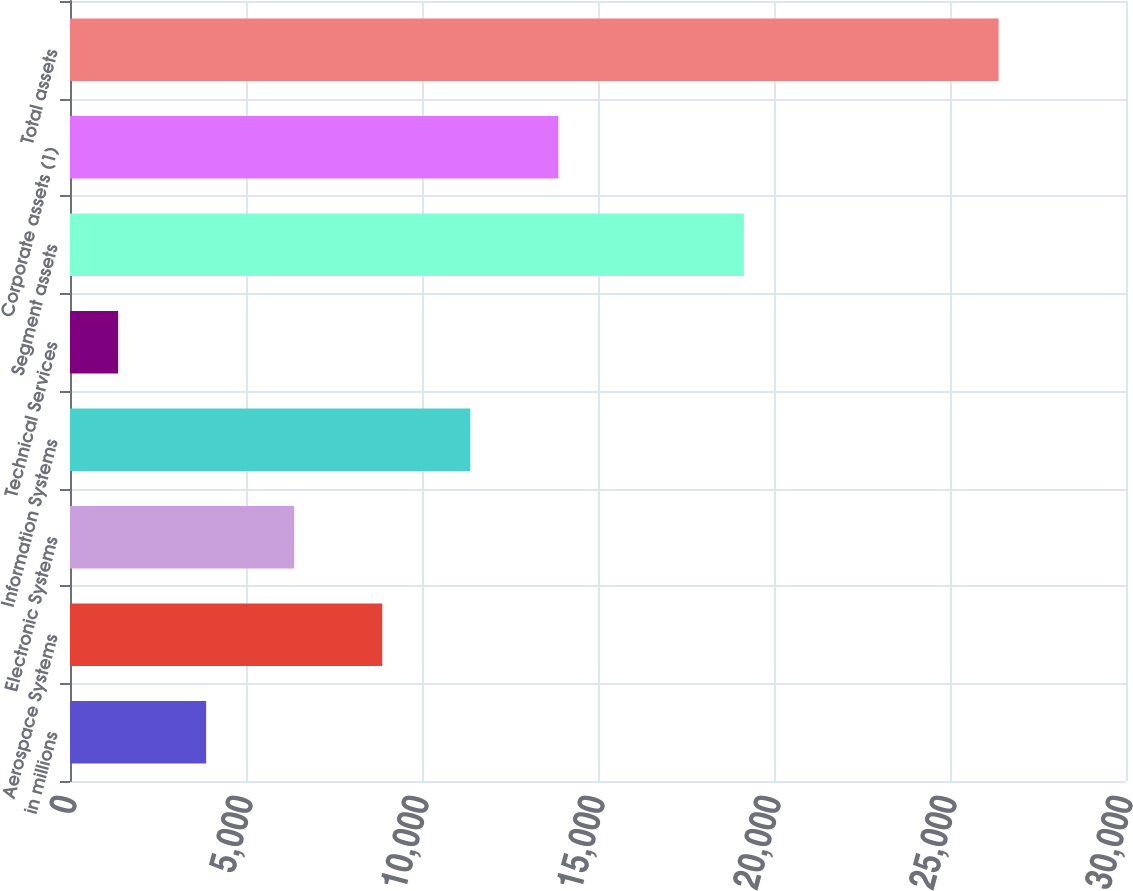<chart> <loc_0><loc_0><loc_500><loc_500><bar_chart><fcel>in millions<fcel>Aerospace Systems<fcel>Electronic Systems<fcel>Information Systems<fcel>Technical Services<fcel>Segment assets<fcel>Corporate assets (1)<fcel>Total assets<nl><fcel>3868.4<fcel>8871.2<fcel>6369.8<fcel>11372.6<fcel>1367<fcel>19144<fcel>13874<fcel>26381<nl></chart> 